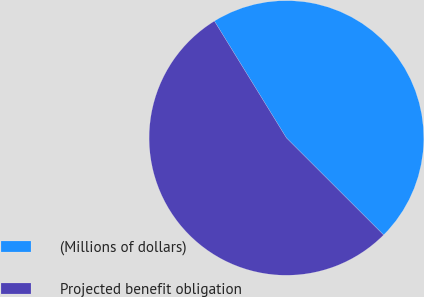Convert chart. <chart><loc_0><loc_0><loc_500><loc_500><pie_chart><fcel>(Millions of dollars)<fcel>Projected benefit obligation<nl><fcel>46.28%<fcel>53.72%<nl></chart> 